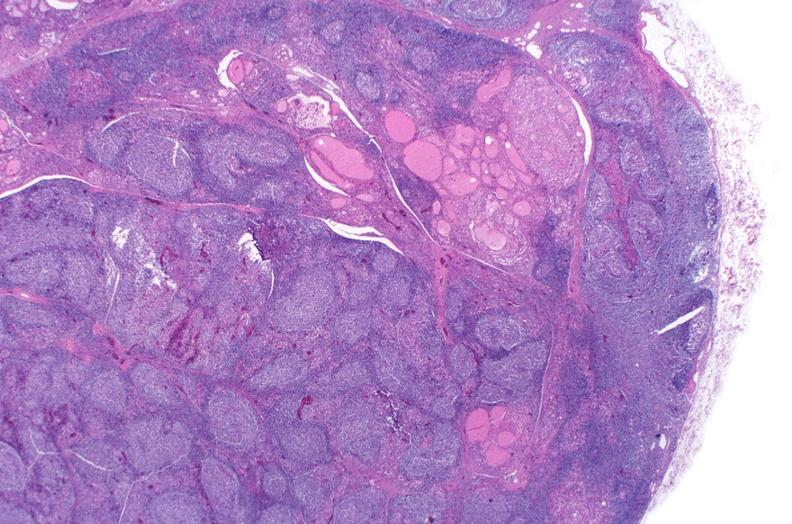does hemorrhage associated with placental abruption show hashimoto 's thyroiditis?
Answer the question using a single word or phrase. No 